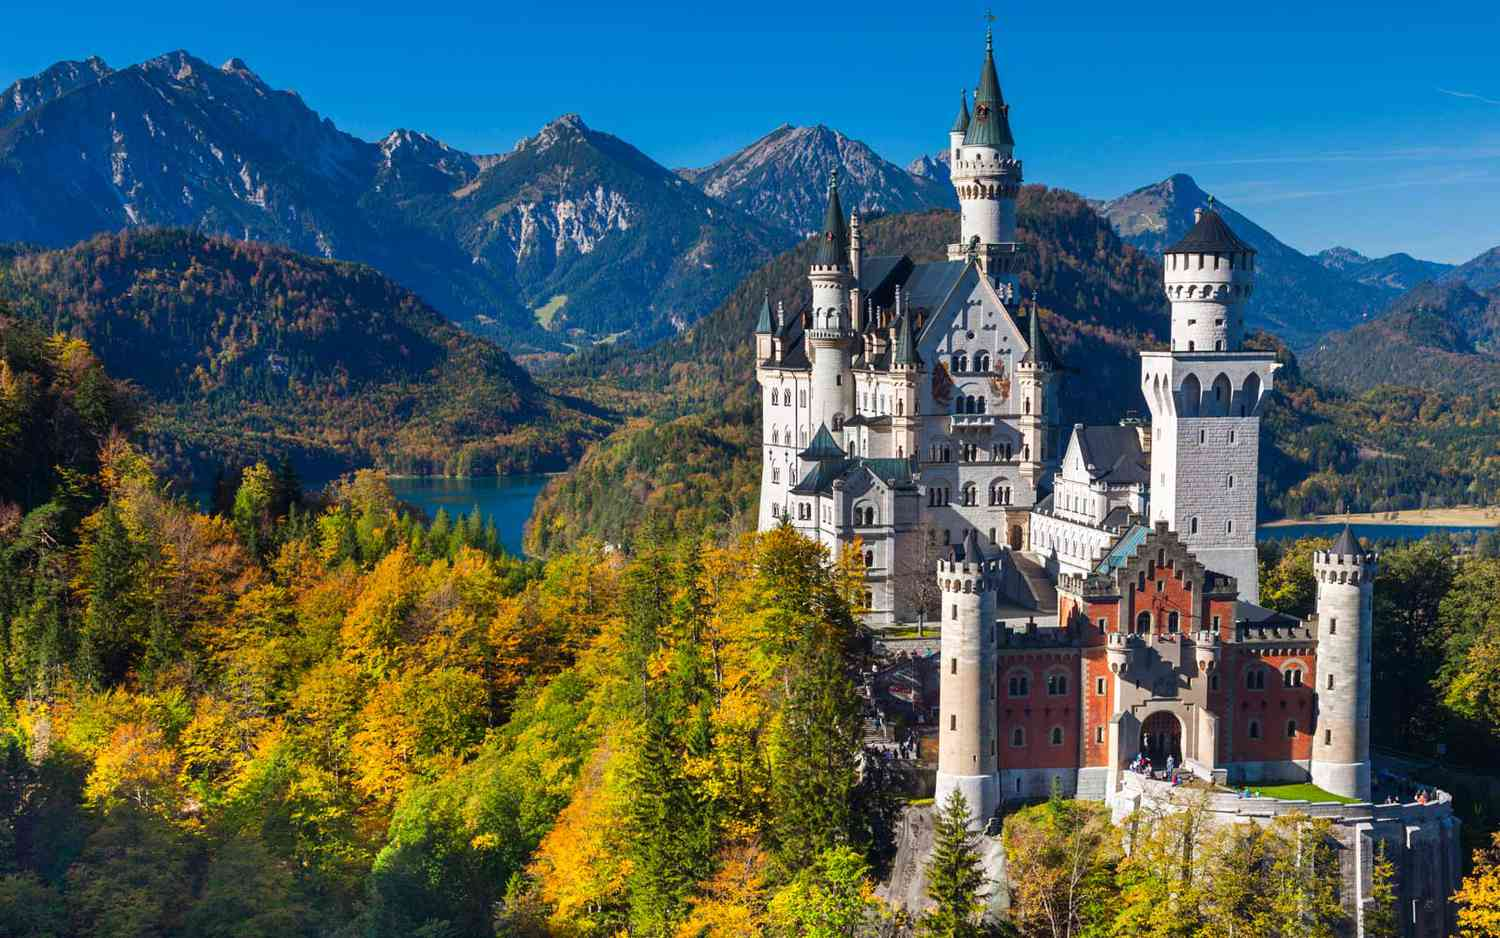Describe the following image. The image showcases the stunning Neuschwanstein Castle, a 19th-century Romanesque Revival palace that majestically sits atop a rugged hill near the village of Hohenschwangau in southwest Bavaria, Germany. The castle's pristine white façade beautifully contrasts against the clear blue sky, while its red roofs introduce a delightful burst of color. A series of ornate turrets and towers accentuate the castle’s grandeur.

Photographed from a distance, the image allows us to appreciate the full expanse of the castle and its surrounding landscape. Enveloped by lush, vibrant autumn foliage, the scene is further enriched by a placid lake and towering mountains in the backdrop. This picturesque setting highlights both the architectural elegance of the 19th century and the enduring natural beauty of Bavaria, capturing a timeless allure that speaks of historical opulence and scenic splendor. 